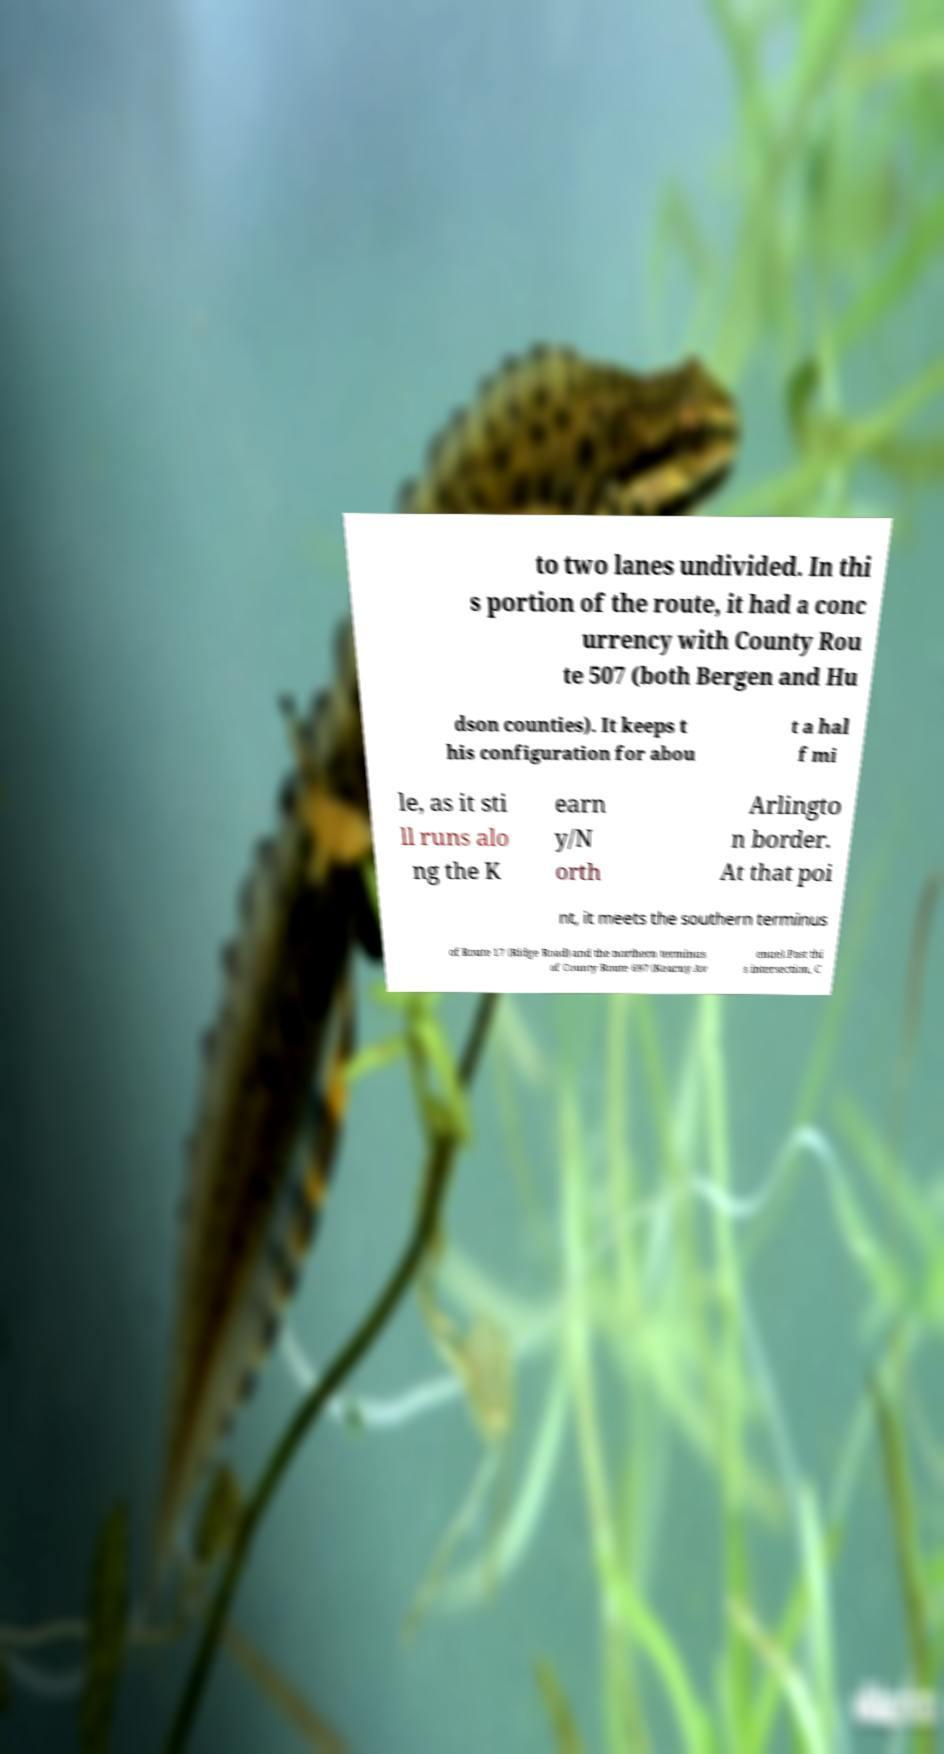Can you read and provide the text displayed in the image?This photo seems to have some interesting text. Can you extract and type it out for me? to two lanes undivided. In thi s portion of the route, it had a conc urrency with County Rou te 507 (both Bergen and Hu dson counties). It keeps t his configuration for abou t a hal f mi le, as it sti ll runs alo ng the K earn y/N orth Arlingto n border. At that poi nt, it meets the southern terminus of Route 17 (Ridge Road) and the northern terminus of County Route 697 (Kearny Av enue).Past thi s intersection, C 